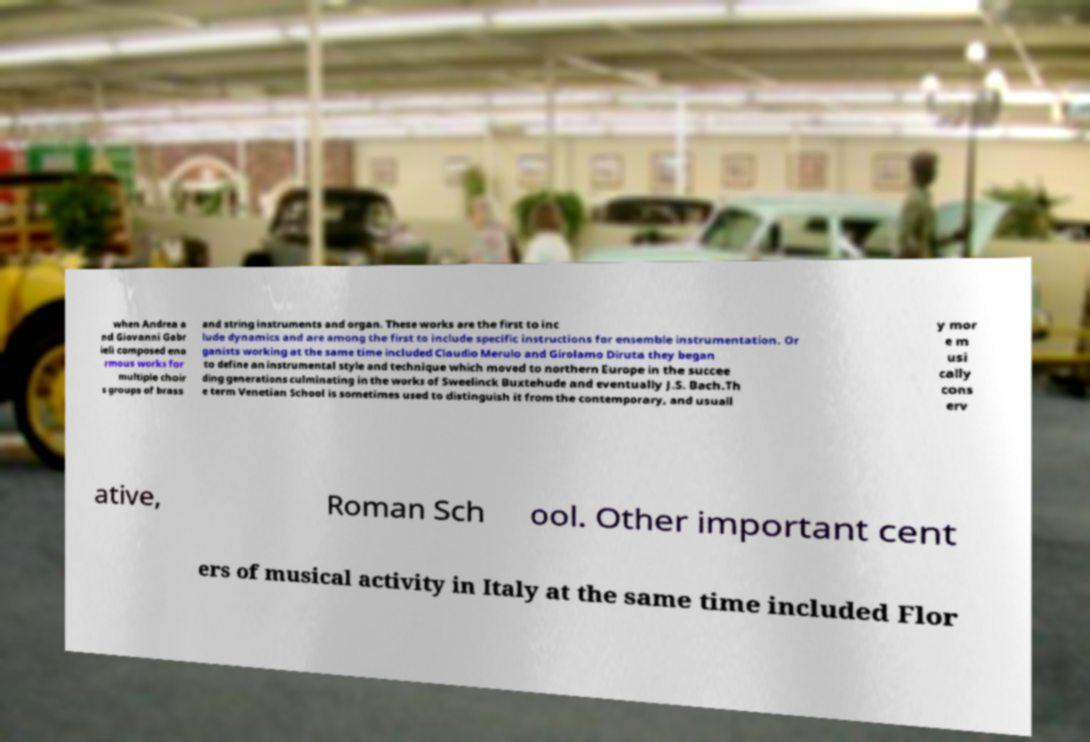What messages or text are displayed in this image? I need them in a readable, typed format. when Andrea a nd Giovanni Gabr ieli composed eno rmous works for multiple choir s groups of brass and string instruments and organ. These works are the first to inc lude dynamics and are among the first to include specific instructions for ensemble instrumentation. Or ganists working at the same time included Claudio Merulo and Girolamo Diruta they began to define an instrumental style and technique which moved to northern Europe in the succee ding generations culminating in the works of Sweelinck Buxtehude and eventually J.S. Bach.Th e term Venetian School is sometimes used to distinguish it from the contemporary, and usuall y mor e m usi cally cons erv ative, Roman Sch ool. Other important cent ers of musical activity in Italy at the same time included Flor 